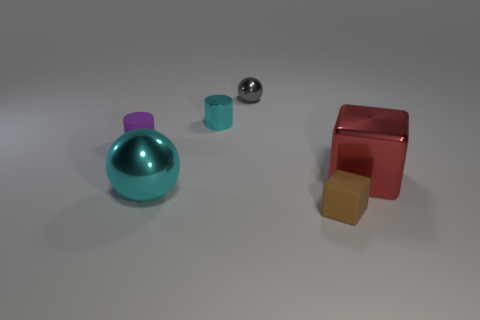Add 4 metal cylinders. How many objects exist? 10 Subtract all spheres. How many objects are left? 4 Subtract all purple things. Subtract all gray matte balls. How many objects are left? 5 Add 1 cyan objects. How many cyan objects are left? 3 Add 2 large shiny spheres. How many large shiny spheres exist? 3 Subtract 0 blue cylinders. How many objects are left? 6 